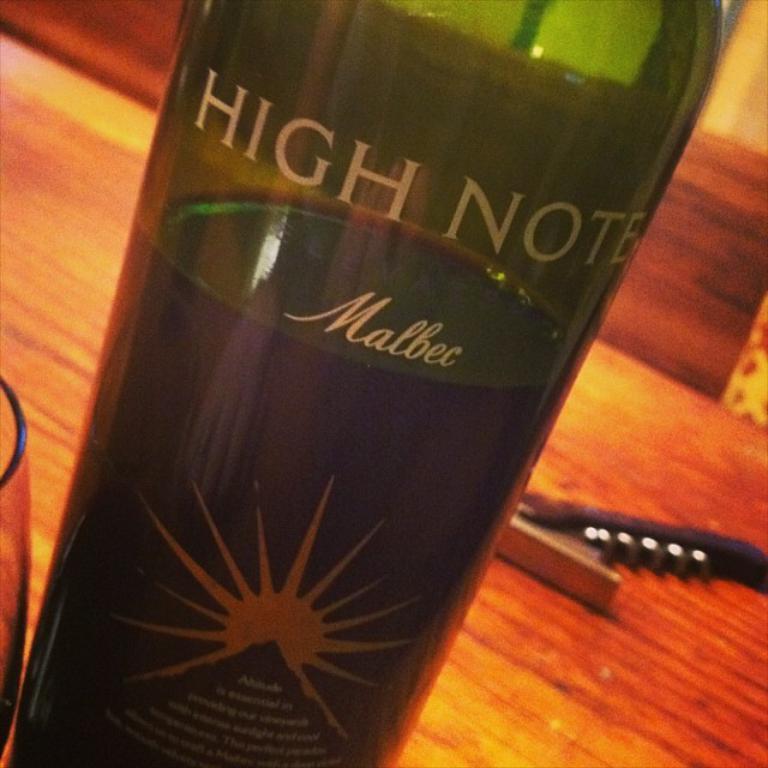What words are on the wine bottle?
Make the answer very short. High note malbec. What is the name of this wine?
Offer a terse response. High note. 